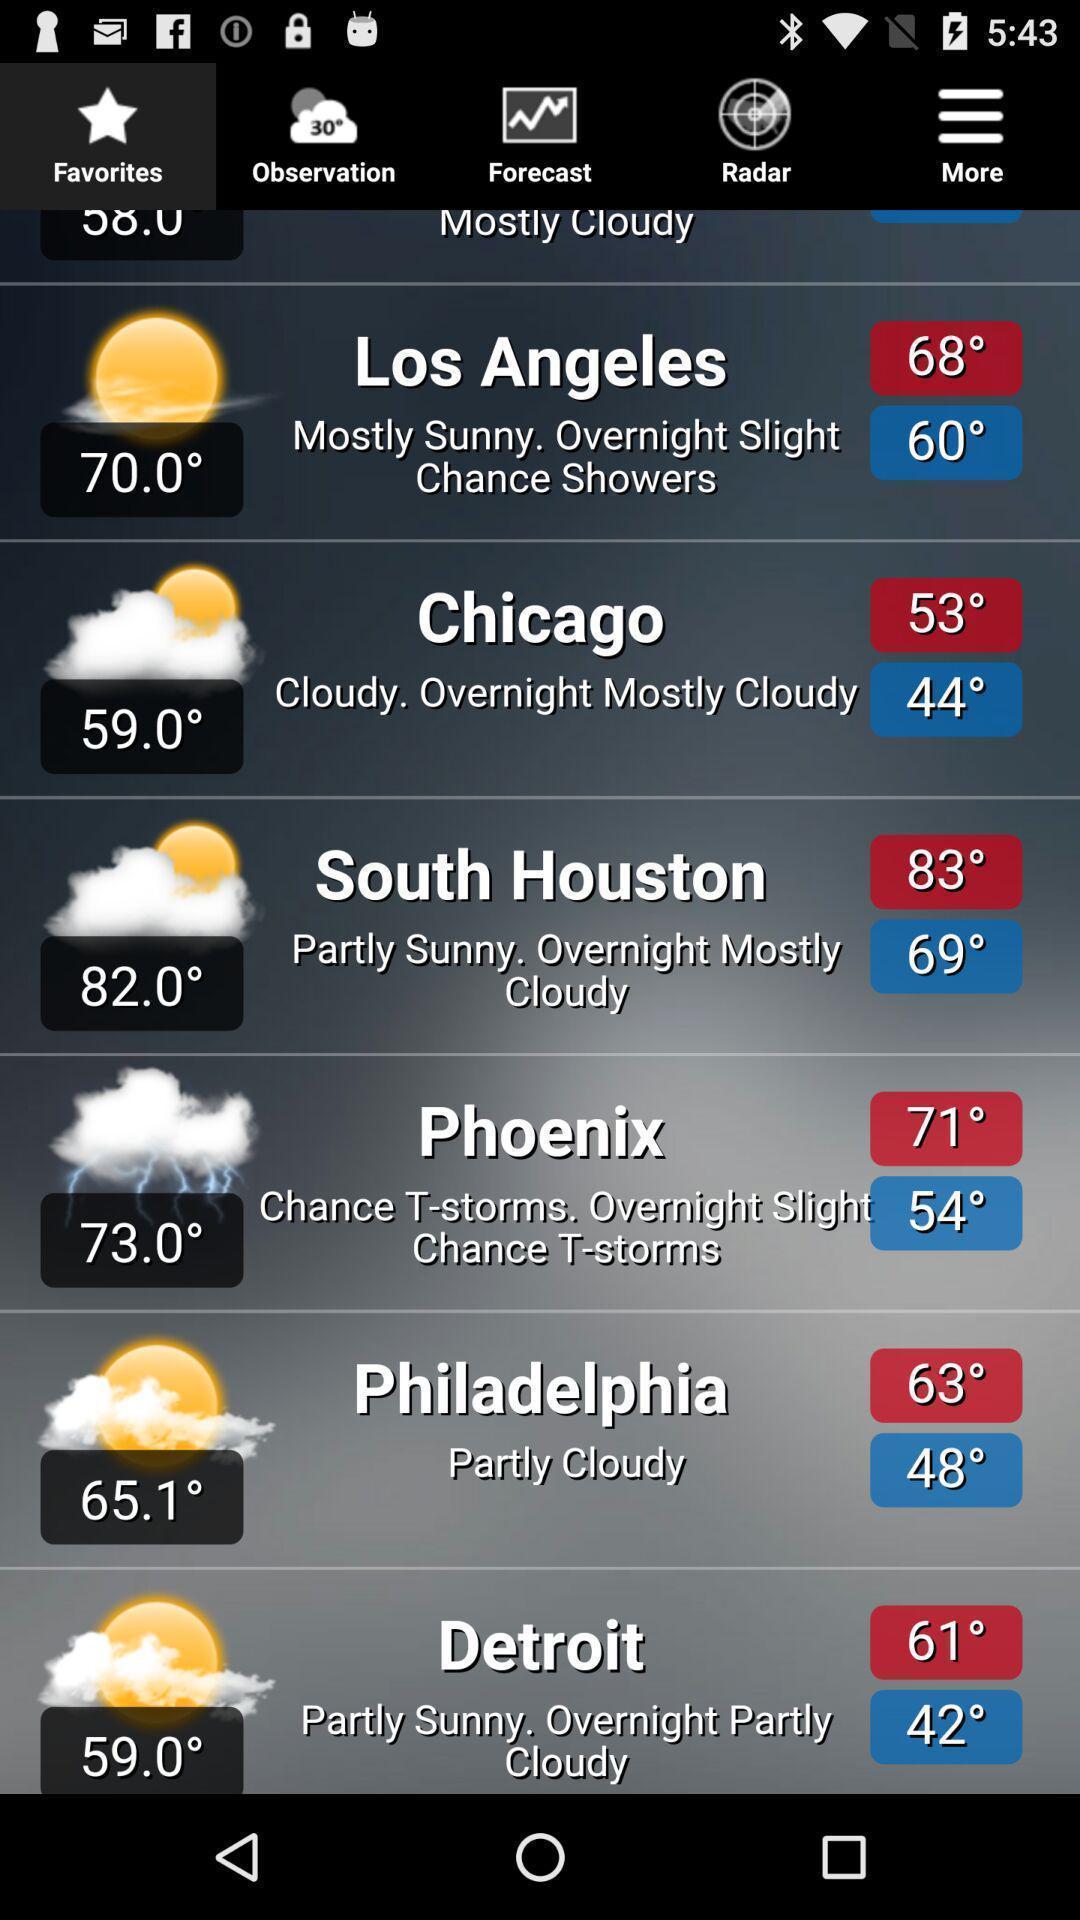Summarize the main components in this picture. Page is showing weather report. 